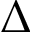<formula> <loc_0><loc_0><loc_500><loc_500>\Delta</formula> 